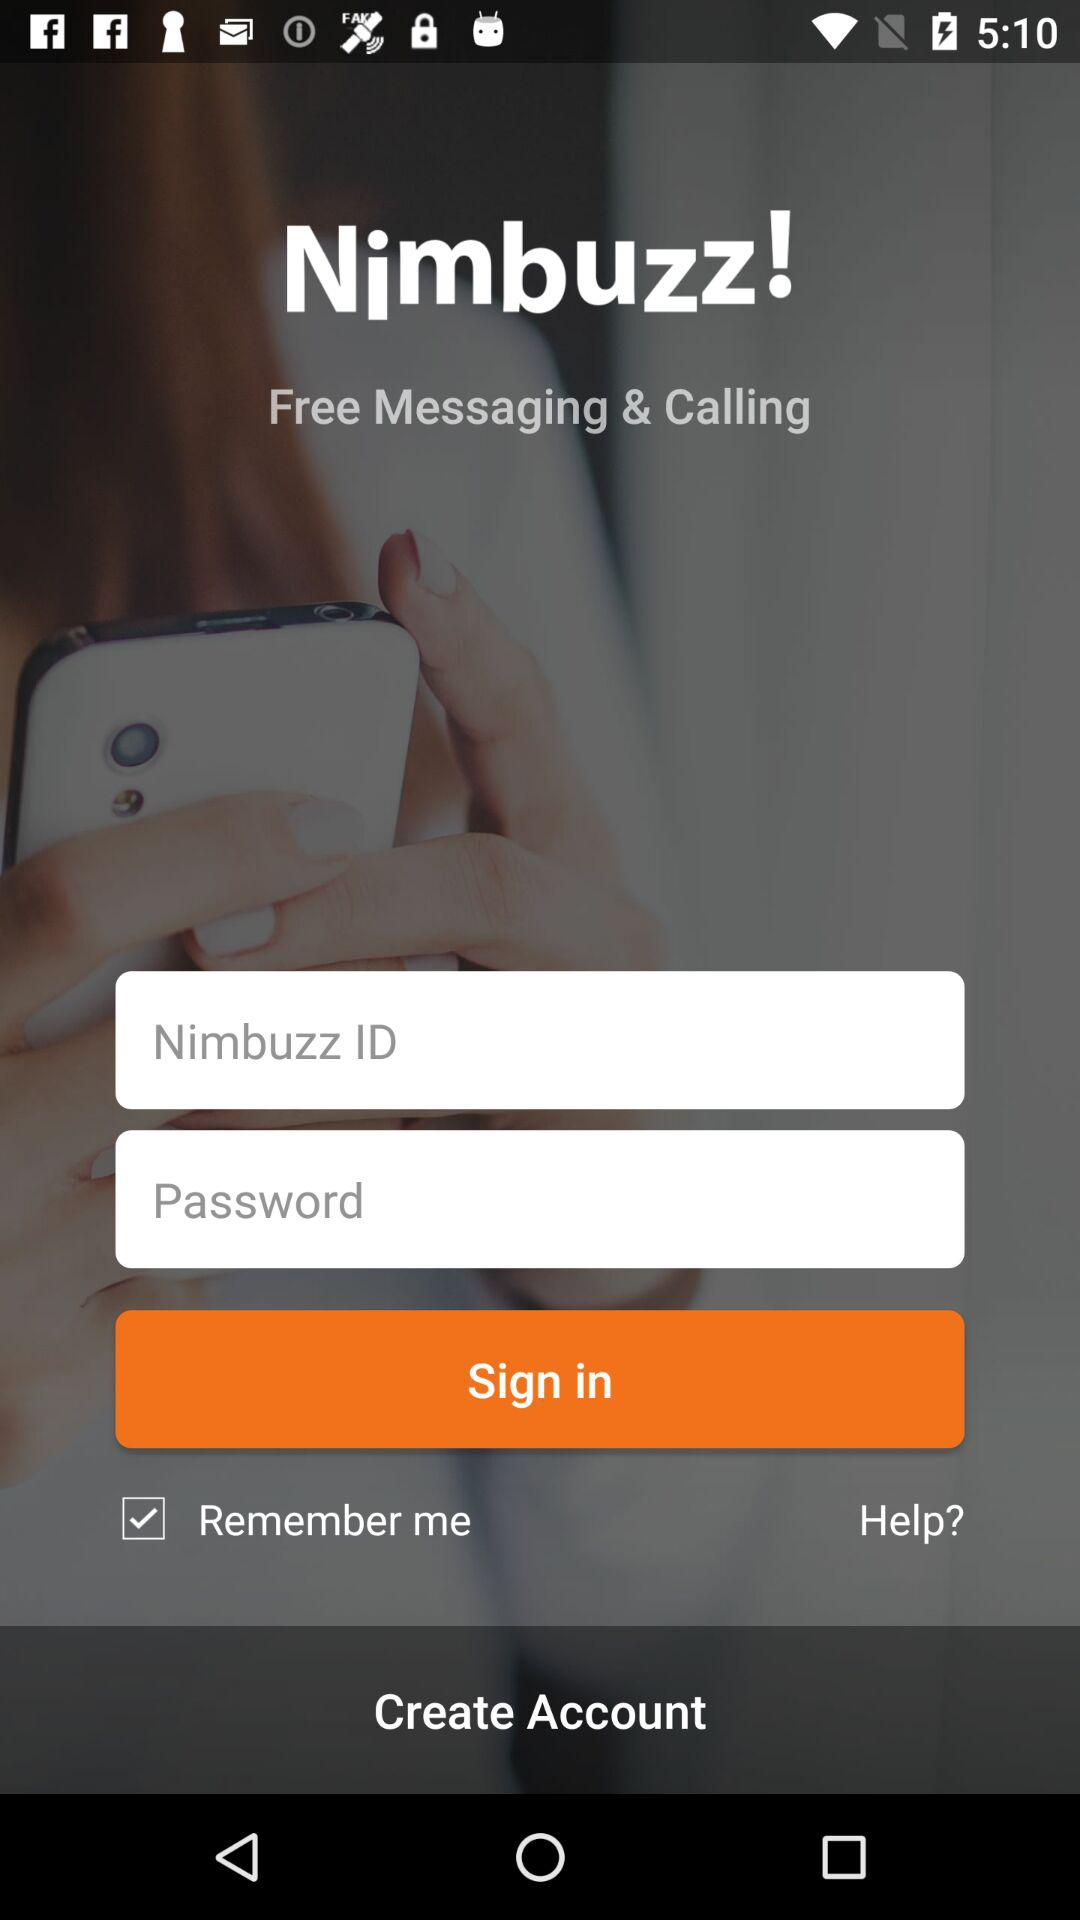What is the charge for messaging and calling? Messaging and calling are free. 